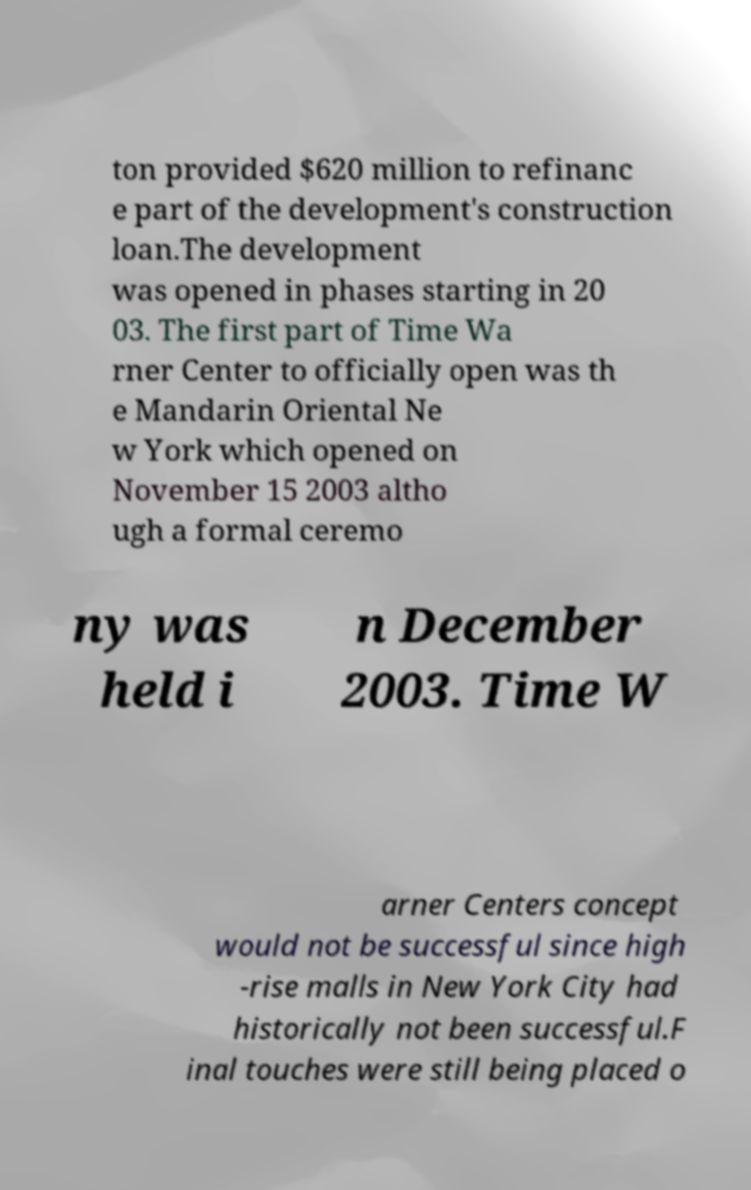What messages or text are displayed in this image? I need them in a readable, typed format. ton provided $620 million to refinanc e part of the development's construction loan.The development was opened in phases starting in 20 03. The first part of Time Wa rner Center to officially open was th e Mandarin Oriental Ne w York which opened on November 15 2003 altho ugh a formal ceremo ny was held i n December 2003. Time W arner Centers concept would not be successful since high -rise malls in New York City had historically not been successful.F inal touches were still being placed o 